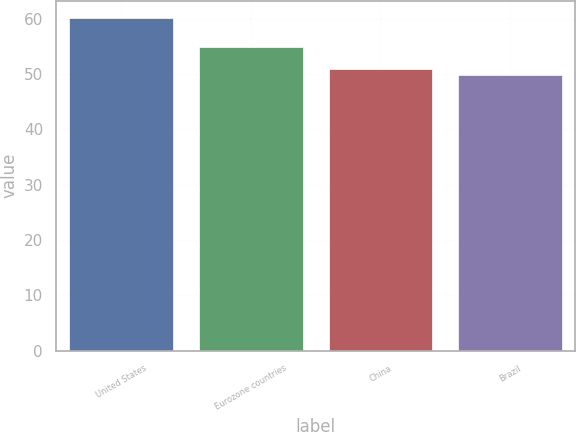<chart> <loc_0><loc_0><loc_500><loc_500><bar_chart><fcel>United States<fcel>Eurozone countries<fcel>China<fcel>Brazil<nl><fcel>60.2<fcel>54.9<fcel>51<fcel>49.8<nl></chart> 